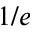Convert formula to latex. <formula><loc_0><loc_0><loc_500><loc_500>1 / e</formula> 